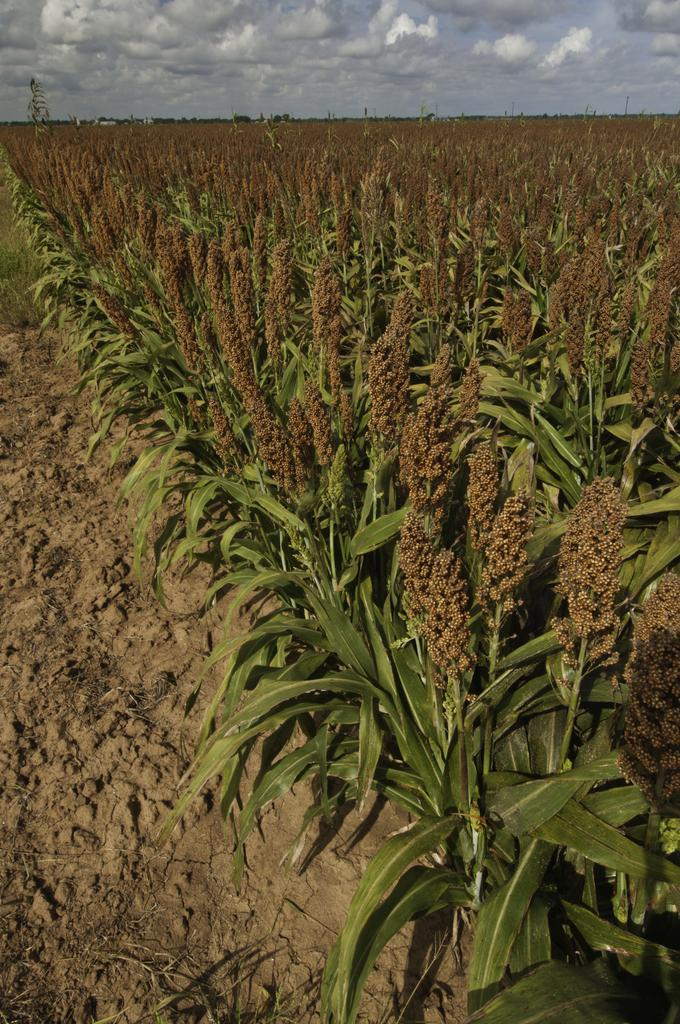What type of terrain is depicted in the image? There is mud in the image. What else can be seen in the image besides the mud? There are multiple plants in the image. What is visible in the background of the image? The sky is visible in the background of the image. How would you describe the weather based on the appearance of the sky? The sky appears to be cloudy. What note is the bird singing in the image? There is no bird present in the image, so it is not possible to determine what note it might be singing. 